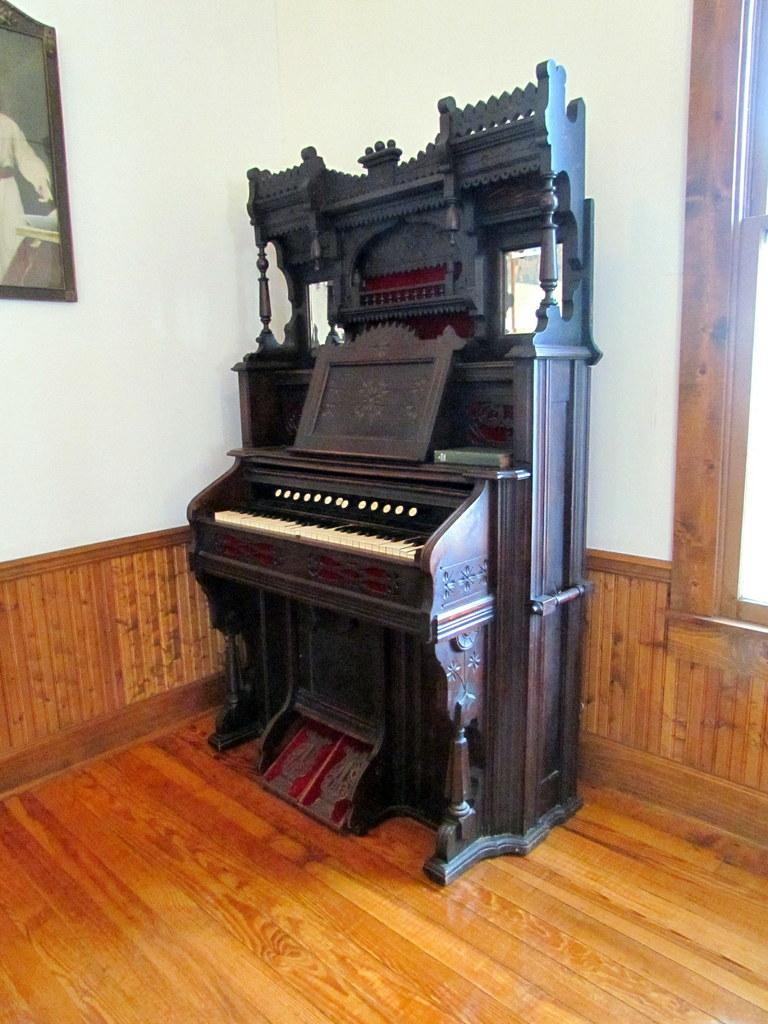What musical instrument is present in the image? There is a piano in the image. What type of sound does the piano produce? The piano produces musical notes when its keys are pressed. Can you describe the appearance of the piano in the image? The image shows a piano with a keyboard and a wooden body. What type of jam is being spread on the piano keys in the image? There is no jam present in the image; it features a piano with no additional items or activities. 